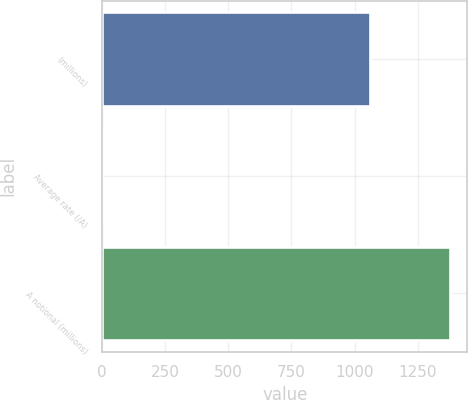<chart> <loc_0><loc_0><loc_500><loc_500><bar_chart><fcel>(millions)<fcel>Average rate (/A)<fcel>A notional (millions)<nl><fcel>1060<fcel>0.77<fcel>1378<nl></chart> 